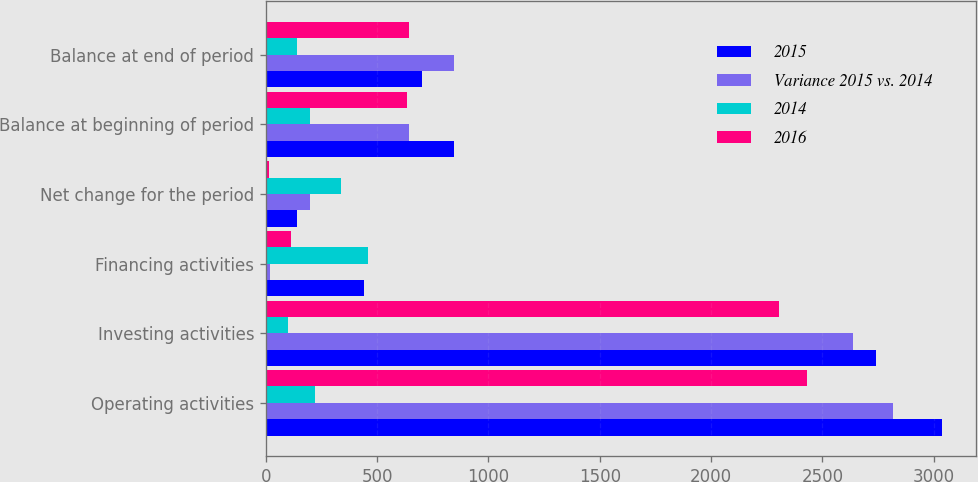<chart> <loc_0><loc_0><loc_500><loc_500><stacked_bar_chart><ecel><fcel>Operating activities<fcel>Investing activities<fcel>Financing activities<fcel>Net change for the period<fcel>Balance at beginning of period<fcel>Balance at end of period<nl><fcel>2015<fcel>3038<fcel>2739<fcel>440<fcel>141<fcel>843<fcel>702<nl><fcel>Variance 2015 vs. 2014<fcel>2819<fcel>2638<fcel>17<fcel>198<fcel>645<fcel>843<nl><fcel>2014<fcel>219<fcel>101<fcel>457<fcel>339<fcel>198<fcel>141<nl><fcel>2016<fcel>2430<fcel>2304<fcel>114<fcel>12<fcel>633<fcel>645<nl></chart> 